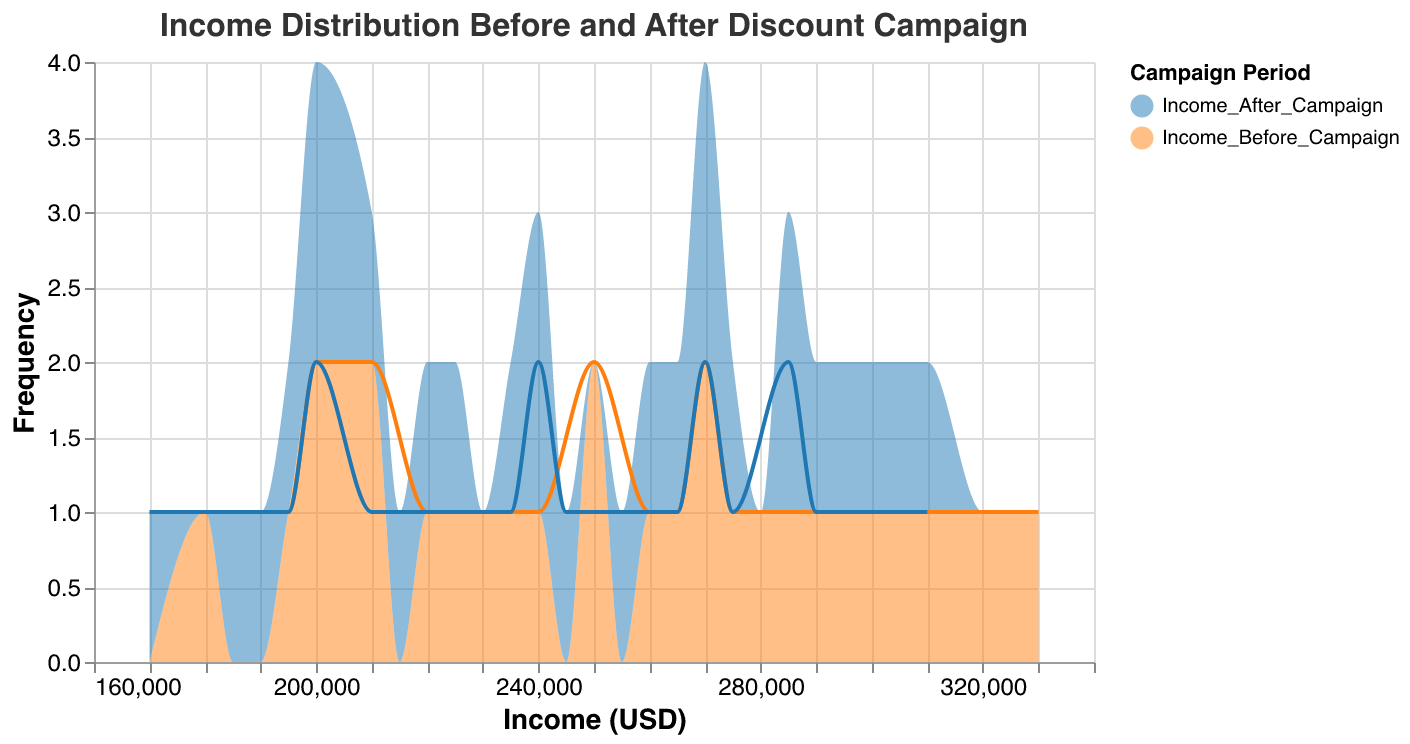What is the title of the figure? The title of the figure is indicated at the top of the plot.
Answer: Income Distribution Before and After Discount Campaign Which campaign period has more customers with an income around 295,000 USD? Look at the x-axis value around 295,000 USD and compare the frequency heights of the two colors representing different periods.
Answer: Before Campaign What's the color used for the "Income After Campaign" period? The legend indicates the color associated with the "Income After Campaign" period.
Answer: Orange What is the maximum frequency for incomes during the "Income After Campaign" period? The y-axis shows the frequency, and the peak height of the orange area indicates this value.
Answer: 2 How did the peak income frequency shift after the discount campaign? Observe the highest frequency values before and after the campaign and note any changes in their positions along the x-axis.
Answer: Shifted towards lower incomes What is the most represented income range before the campaign started? Look for the peak of the blue area and note the corresponding income range on the x-axis.
Answer: 250,000 to 270,000 USD How does the income distribution before the campaign compare to after in the range of 200,000 to 210,000 USD? Compare the frequency heights of the blue and orange areas between the x-axis values of 200,000 and 210,000 USD.
Answer: Before Campaign has more customers What is the general trend of customer income after the discount campaign? Observe the shape of the orange area across different income levels on the x-axis to determine if income levels generally increased, decreased, or stayed the same.
Answer: Decreased Which income period shows a wider distribution of incomes? Compare the width of the blue and orange areas along the x-axis to see which period covers a broader range of incomes.
Answer: Before Campaign How many customers had an income of 210,000-220,000 USD after the discount campaign? Look at the frequency (y-axis) for the orange area within the 210,000-220,000 USD range on the x-axis.
Answer: 2 